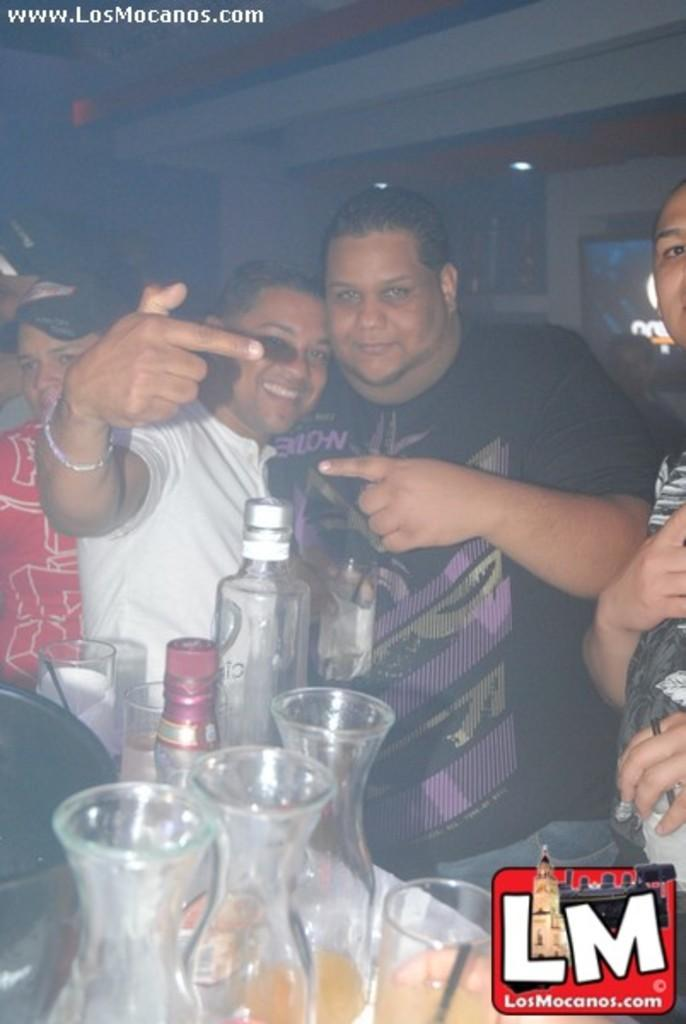What can be observed about the people in the image? There are people standing in the image, and they have smiles on their faces. What objects are visible in the image besides the people? There are bottles and glasses visible in the image. What type of knee can be seen in the image? There is no knee visible in the image; it only shows people standing with smiles on their faces and some bottles and glasses. 